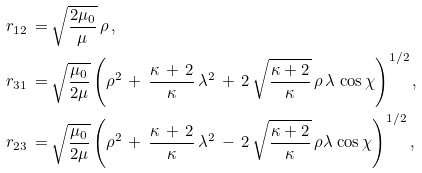Convert formula to latex. <formula><loc_0><loc_0><loc_500><loc_500>r _ { 1 2 } \, = \, & \sqrt { \frac { 2 \mu _ { 0 } } { \mu } } \, \rho \, , \\ r _ { 3 1 } \, = \, & \sqrt { \frac { \mu _ { 0 } } { 2 \mu } } \left ( \rho ^ { 2 } \, + \, \frac { \kappa \, + \, 2 } { \kappa } \, \lambda ^ { 2 } \, + \, 2 \, \sqrt { \frac { \kappa + 2 } { \kappa } } \, \rho \, \lambda \, \cos \chi \right ) ^ { 1 / 2 } , \\ r _ { 2 3 } \, = \, & \sqrt { \frac { \mu _ { 0 } } { 2 \mu } } \left ( \rho ^ { 2 } \, + \, \frac { \kappa \, + \, 2 } { \kappa } \, \lambda ^ { 2 } \, - \, 2 \, \sqrt { \frac { \kappa + 2 } { \kappa } } \, \rho \lambda \, \cos \chi \right ) ^ { 1 / 2 } ,</formula> 